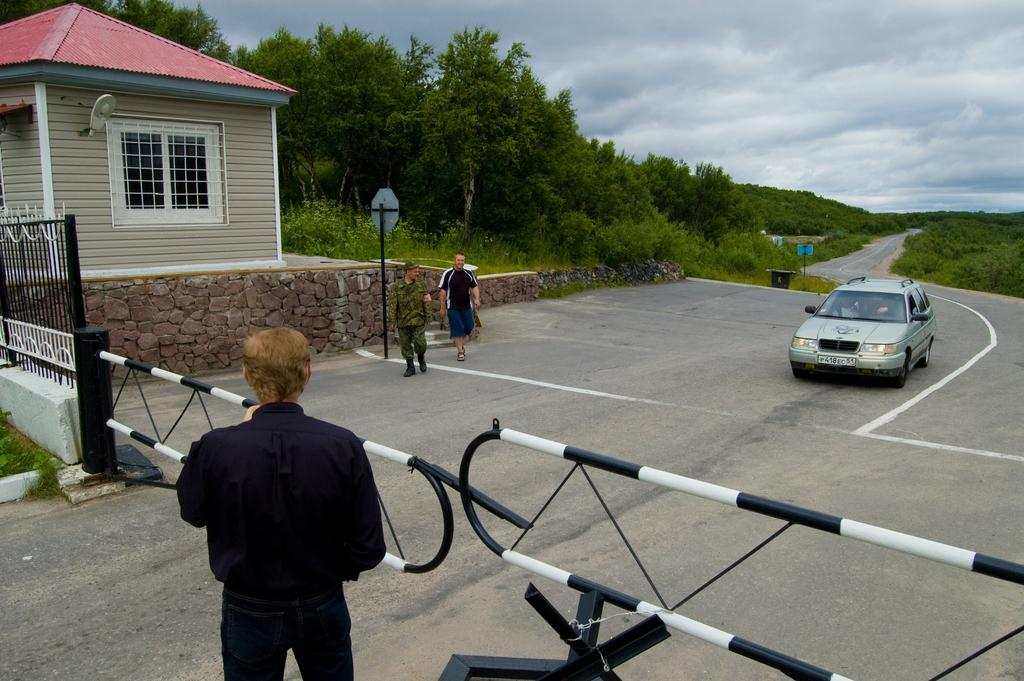What type of structure is visible in the image? There is a house in the image. What is located near the house? There is a fence in the image. Are there any people present in the image? Yes, there are people in the image. What else can be seen in the image besides the house and people? There is a sign pole, a car, grass, trees, the sky, and clouds visible in the image. How many lizards are sitting on the manager's heart in the image? There are no lizards or managers present in the image, and therefore no such interaction can be observed. 